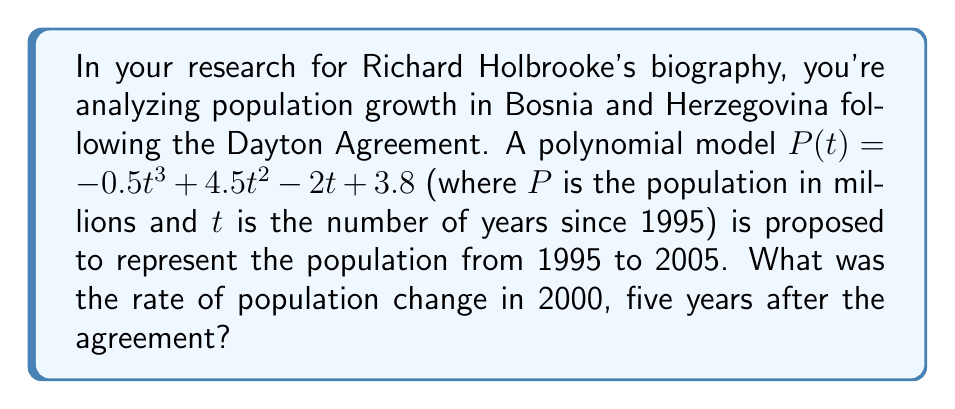Show me your answer to this math problem. To find the rate of population change in 2000, we need to calculate the derivative of the polynomial function $P(t)$ and evaluate it at $t=5$ (since 2000 is 5 years after 1995).

1) First, let's find the derivative of $P(t)$:
   $$P(t) = -0.5t^3 + 4.5t^2 - 2t + 3.8$$
   $$P'(t) = -1.5t^2 + 9t - 2$$

2) Now, we evaluate $P'(t)$ at $t=5$:
   $$P'(5) = -1.5(5^2) + 9(5) - 2$$
   $$= -1.5(25) + 45 - 2$$
   $$= -37.5 + 45 - 2$$
   $$= 5.5$$

3) The units of this rate are in millions per year, as $P(t)$ was in millions and $t$ was in years.

Therefore, the rate of population change in 2000 was 5.5 million people per year.
Answer: 5.5 million people per year 